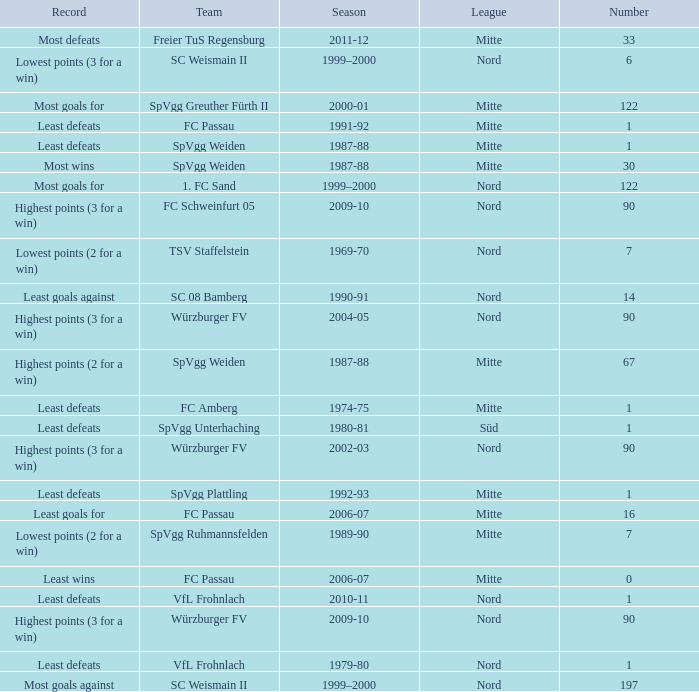What season has a number less than 90, Mitte as the league and spvgg ruhmannsfelden as the team? 1989-90. Could you parse the entire table? {'header': ['Record', 'Team', 'Season', 'League', 'Number'], 'rows': [['Most defeats', 'Freier TuS Regensburg', '2011-12', 'Mitte', '33'], ['Lowest points (3 for a win)', 'SC Weismain II', '1999–2000', 'Nord', '6'], ['Most goals for', 'SpVgg Greuther Fürth II', '2000-01', 'Mitte', '122'], ['Least defeats', 'FC Passau', '1991-92', 'Mitte', '1'], ['Least defeats', 'SpVgg Weiden', '1987-88', 'Mitte', '1'], ['Most wins', 'SpVgg Weiden', '1987-88', 'Mitte', '30'], ['Most goals for', '1. FC Sand', '1999–2000', 'Nord', '122'], ['Highest points (3 for a win)', 'FC Schweinfurt 05', '2009-10', 'Nord', '90'], ['Lowest points (2 for a win)', 'TSV Staffelstein', '1969-70', 'Nord', '7'], ['Least goals against', 'SC 08 Bamberg', '1990-91', 'Nord', '14'], ['Highest points (3 for a win)', 'Würzburger FV', '2004-05', 'Nord', '90'], ['Highest points (2 for a win)', 'SpVgg Weiden', '1987-88', 'Mitte', '67'], ['Least defeats', 'FC Amberg', '1974-75', 'Mitte', '1'], ['Least defeats', 'SpVgg Unterhaching', '1980-81', 'Süd', '1'], ['Highest points (3 for a win)', 'Würzburger FV', '2002-03', 'Nord', '90'], ['Least defeats', 'SpVgg Plattling', '1992-93', 'Mitte', '1'], ['Least goals for', 'FC Passau', '2006-07', 'Mitte', '16'], ['Lowest points (2 for a win)', 'SpVgg Ruhmannsfelden', '1989-90', 'Mitte', '7'], ['Least wins', 'FC Passau', '2006-07', 'Mitte', '0'], ['Least defeats', 'VfL Frohnlach', '2010-11', 'Nord', '1'], ['Highest points (3 for a win)', 'Würzburger FV', '2009-10', 'Nord', '90'], ['Least defeats', 'VfL Frohnlach', '1979-80', 'Nord', '1'], ['Most goals against', 'SC Weismain II', '1999–2000', 'Nord', '197']]} 